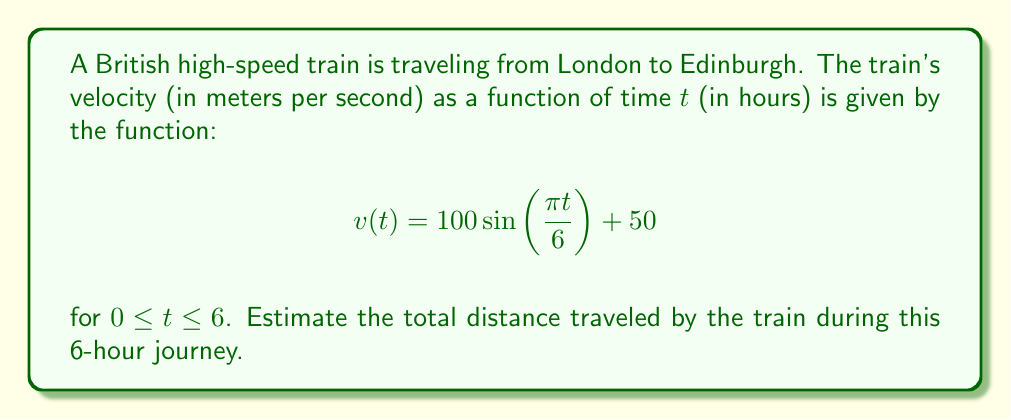Can you answer this question? To estimate the total distance traveled by the train, we need to calculate the definite integral of the velocity function over the given time interval. This is because distance is the integral of velocity with respect to time.

1. Set up the integral:
   $$\text{Distance} = \int_0^6 v(t) \, dt = \int_0^6 (100 \sin(\frac{\pi t}{6}) + 50) \, dt$$

2. Split the integral:
   $$\int_0^6 100 \sin(\frac{\pi t}{6}) \, dt + \int_0^6 50 \, dt$$

3. Solve the first part using u-substitution:
   Let $u = \frac{\pi t}{6}$, then $du = \frac{\pi}{6} dt$ and $dt = \frac{6}{\pi} du$
   
   $$100 \int_0^{\pi} \sin(u) \cdot \frac{6}{\pi} \, du = \frac{600}{\pi} [-\cos(u)]_0^{\pi} = \frac{600}{\pi} [-\cos(\pi) + \cos(0)] = \frac{1200}{\pi}$$

4. Solve the second part:
   $$50 \int_0^6 dt = 50 \cdot 6 = 300$$

5. Sum the results:
   $$\text{Total Distance} = \frac{1200}{\pi} + 300 \approx 681.69 \text{ kilometers}$$

Note: We converted the result to kilometers for a more practical measurement in train travel.
Answer: The estimated total distance traveled by the train is approximately 681.69 kilometers. 